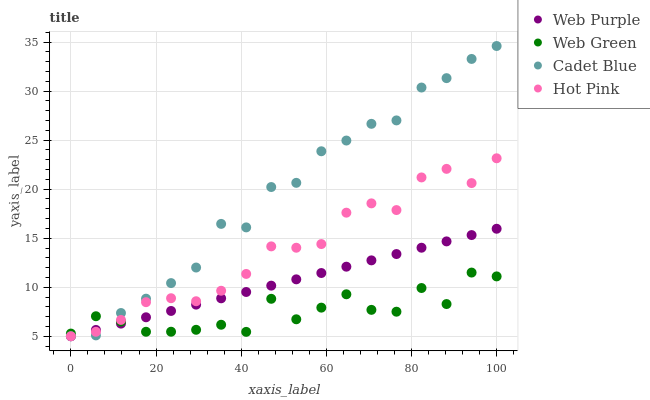Does Web Green have the minimum area under the curve?
Answer yes or no. Yes. Does Cadet Blue have the maximum area under the curve?
Answer yes or no. Yes. Does Cadet Blue have the minimum area under the curve?
Answer yes or no. No. Does Web Green have the maximum area under the curve?
Answer yes or no. No. Is Web Purple the smoothest?
Answer yes or no. Yes. Is Web Green the roughest?
Answer yes or no. Yes. Is Cadet Blue the smoothest?
Answer yes or no. No. Is Cadet Blue the roughest?
Answer yes or no. No. Does Web Purple have the lowest value?
Answer yes or no. Yes. Does Web Green have the lowest value?
Answer yes or no. No. Does Cadet Blue have the highest value?
Answer yes or no. Yes. Does Web Green have the highest value?
Answer yes or no. No. Does Hot Pink intersect Web Purple?
Answer yes or no. Yes. Is Hot Pink less than Web Purple?
Answer yes or no. No. Is Hot Pink greater than Web Purple?
Answer yes or no. No. 